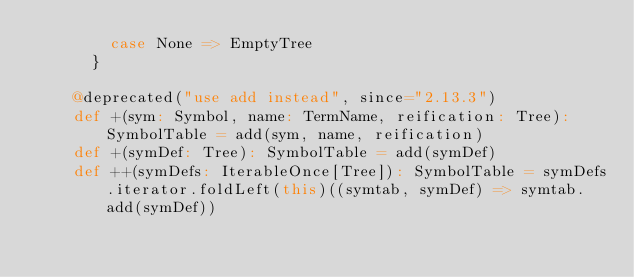Convert code to text. <code><loc_0><loc_0><loc_500><loc_500><_Scala_>        case None => EmptyTree
      }

    @deprecated("use add instead", since="2.13.3")
    def +(sym: Symbol, name: TermName, reification: Tree): SymbolTable = add(sym, name, reification)
    def +(symDef: Tree): SymbolTable = add(symDef)
    def ++(symDefs: IterableOnce[Tree]): SymbolTable = symDefs.iterator.foldLeft(this)((symtab, symDef) => symtab.add(symDef))</code> 